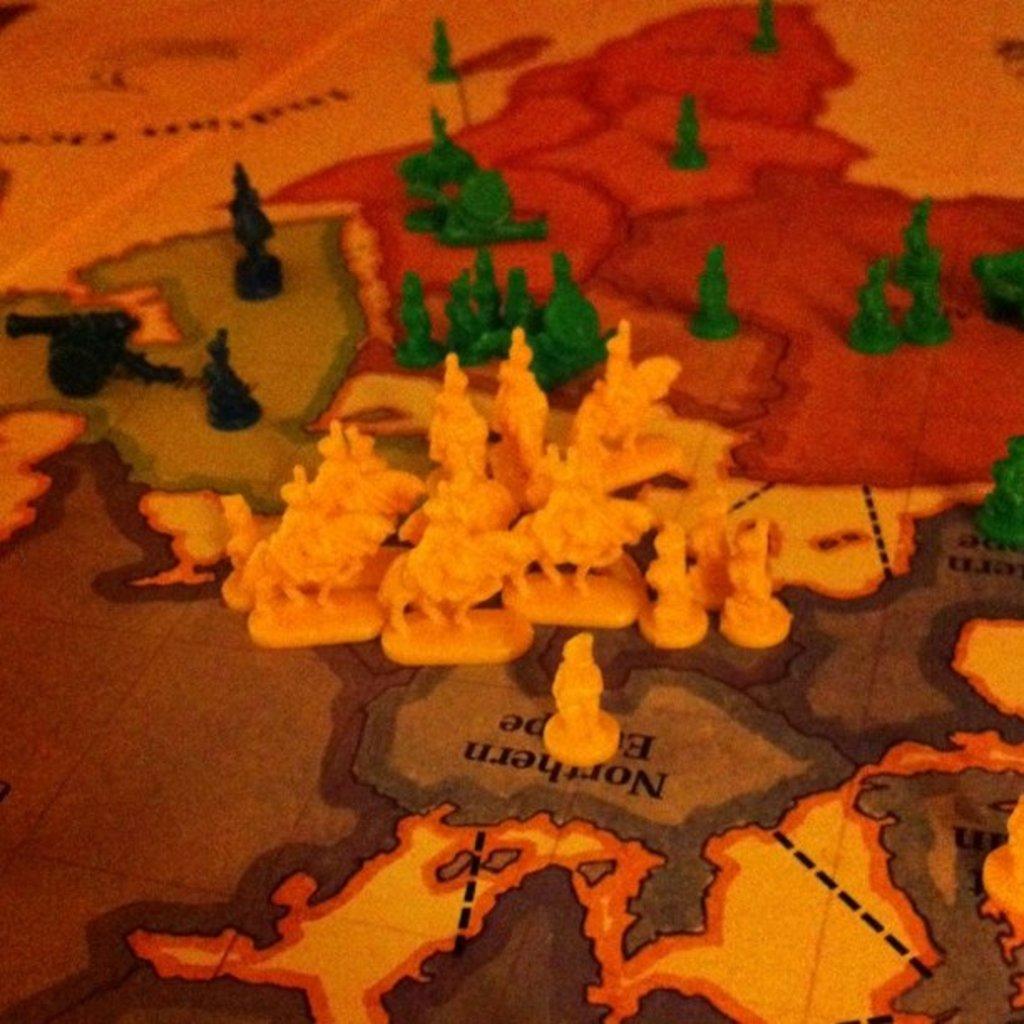In one or two sentences, can you explain what this image depicts? In the image we can see there are coins of different colors kept on the map chart. 